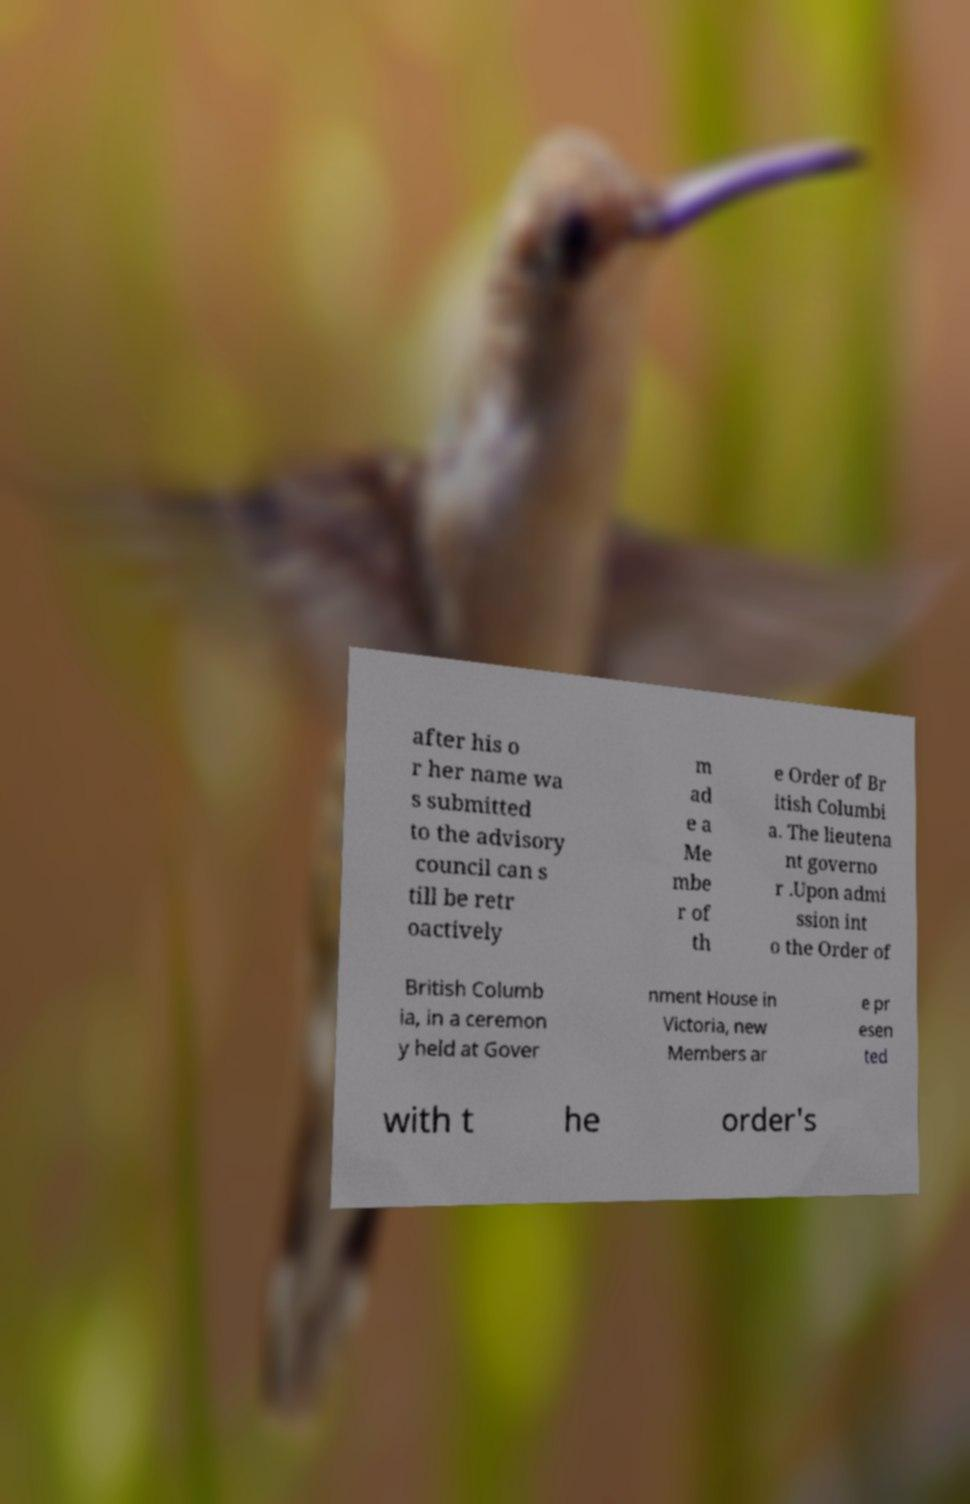Could you extract and type out the text from this image? after his o r her name wa s submitted to the advisory council can s till be retr oactively m ad e a Me mbe r of th e Order of Br itish Columbi a. The lieutena nt governo r .Upon admi ssion int o the Order of British Columb ia, in a ceremon y held at Gover nment House in Victoria, new Members ar e pr esen ted with t he order's 